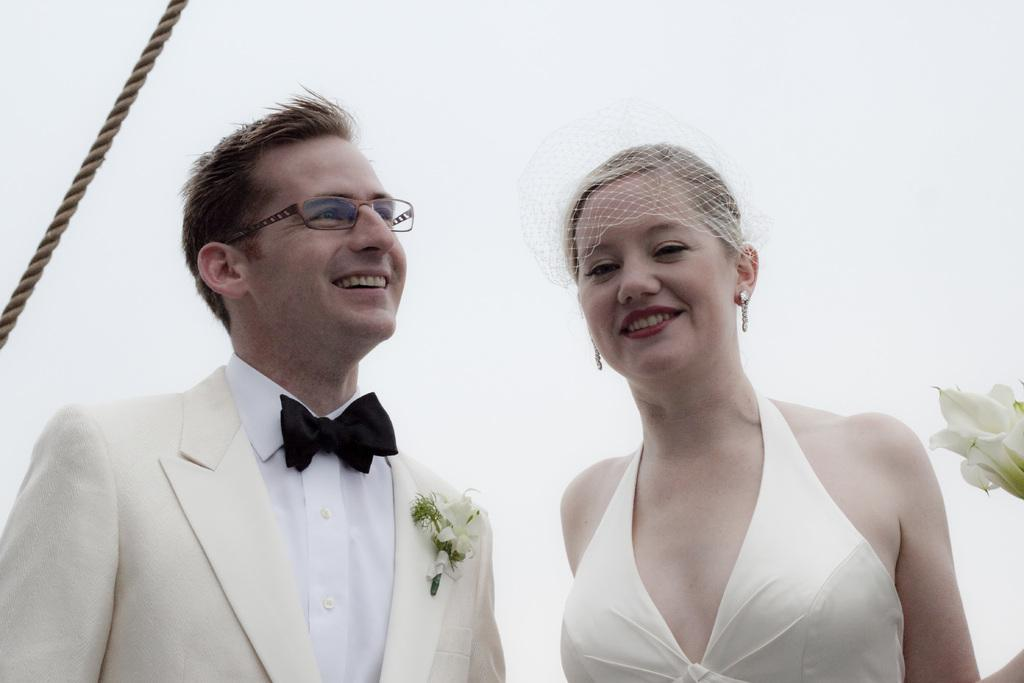Who is present in the image? There is a man and a woman in the image. What are the facial expressions of the people in the image? Both the man and the woman are smiling. What can be seen at the top left side of the image? There is a rope at the top left side of the image. What type of vegetation is on the right side of the image? There are flowers on the right side of the image. What is the pig doing in the image? There is no pig present in the image. What is surprising about the woman's hands in the image? There is no indication of surprise or any unusual hand gestures in the image. 